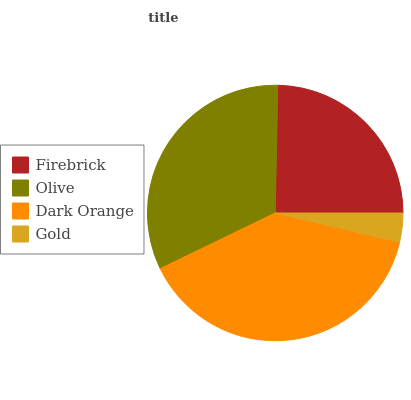Is Gold the minimum?
Answer yes or no. Yes. Is Dark Orange the maximum?
Answer yes or no. Yes. Is Olive the minimum?
Answer yes or no. No. Is Olive the maximum?
Answer yes or no. No. Is Olive greater than Firebrick?
Answer yes or no. Yes. Is Firebrick less than Olive?
Answer yes or no. Yes. Is Firebrick greater than Olive?
Answer yes or no. No. Is Olive less than Firebrick?
Answer yes or no. No. Is Olive the high median?
Answer yes or no. Yes. Is Firebrick the low median?
Answer yes or no. Yes. Is Firebrick the high median?
Answer yes or no. No. Is Olive the low median?
Answer yes or no. No. 